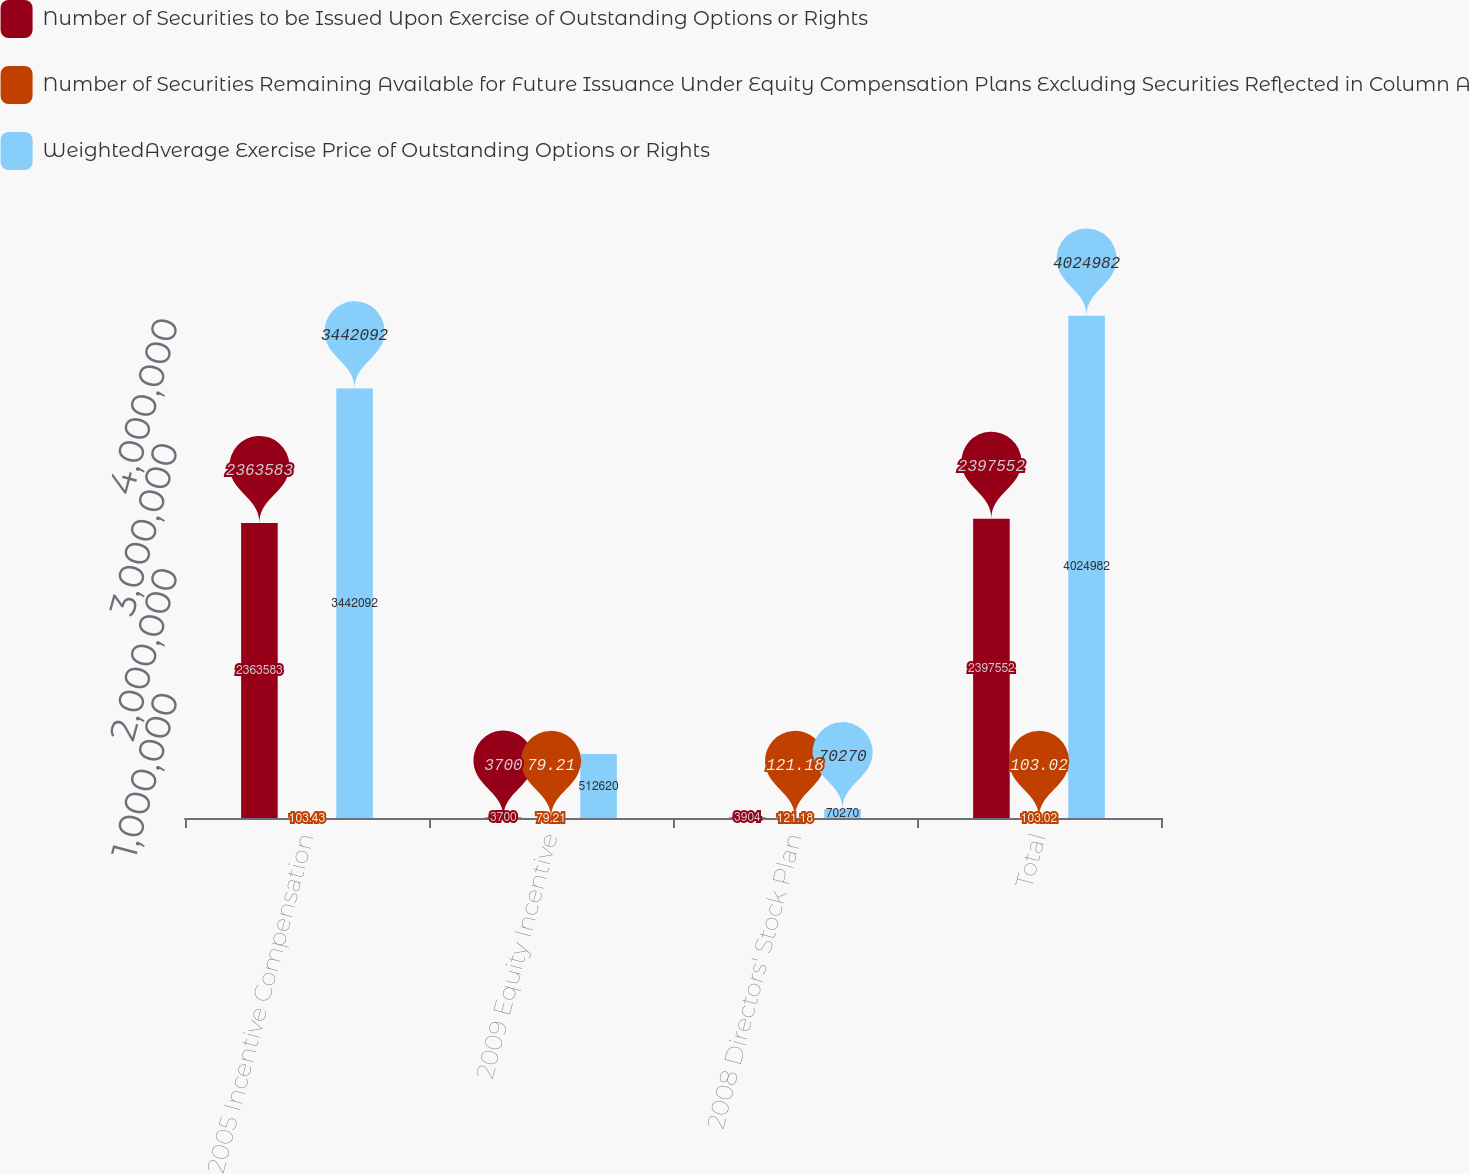<chart> <loc_0><loc_0><loc_500><loc_500><stacked_bar_chart><ecel><fcel>2005 Incentive Compensation<fcel>2009 Equity Incentive<fcel>2008 Directors' Stock Plan<fcel>Total<nl><fcel>Number of Securities to be Issued Upon Exercise of Outstanding Options or Rights<fcel>2.36358e+06<fcel>3700<fcel>3904<fcel>2.39755e+06<nl><fcel>Number of Securities Remaining Available for Future Issuance Under Equity Compensation Plans Excluding Securities Reflected in Column A<fcel>103.43<fcel>79.21<fcel>121.18<fcel>103.02<nl><fcel>WeightedAverage Exercise Price of Outstanding Options or Rights<fcel>3.44209e+06<fcel>512620<fcel>70270<fcel>4.02498e+06<nl></chart> 